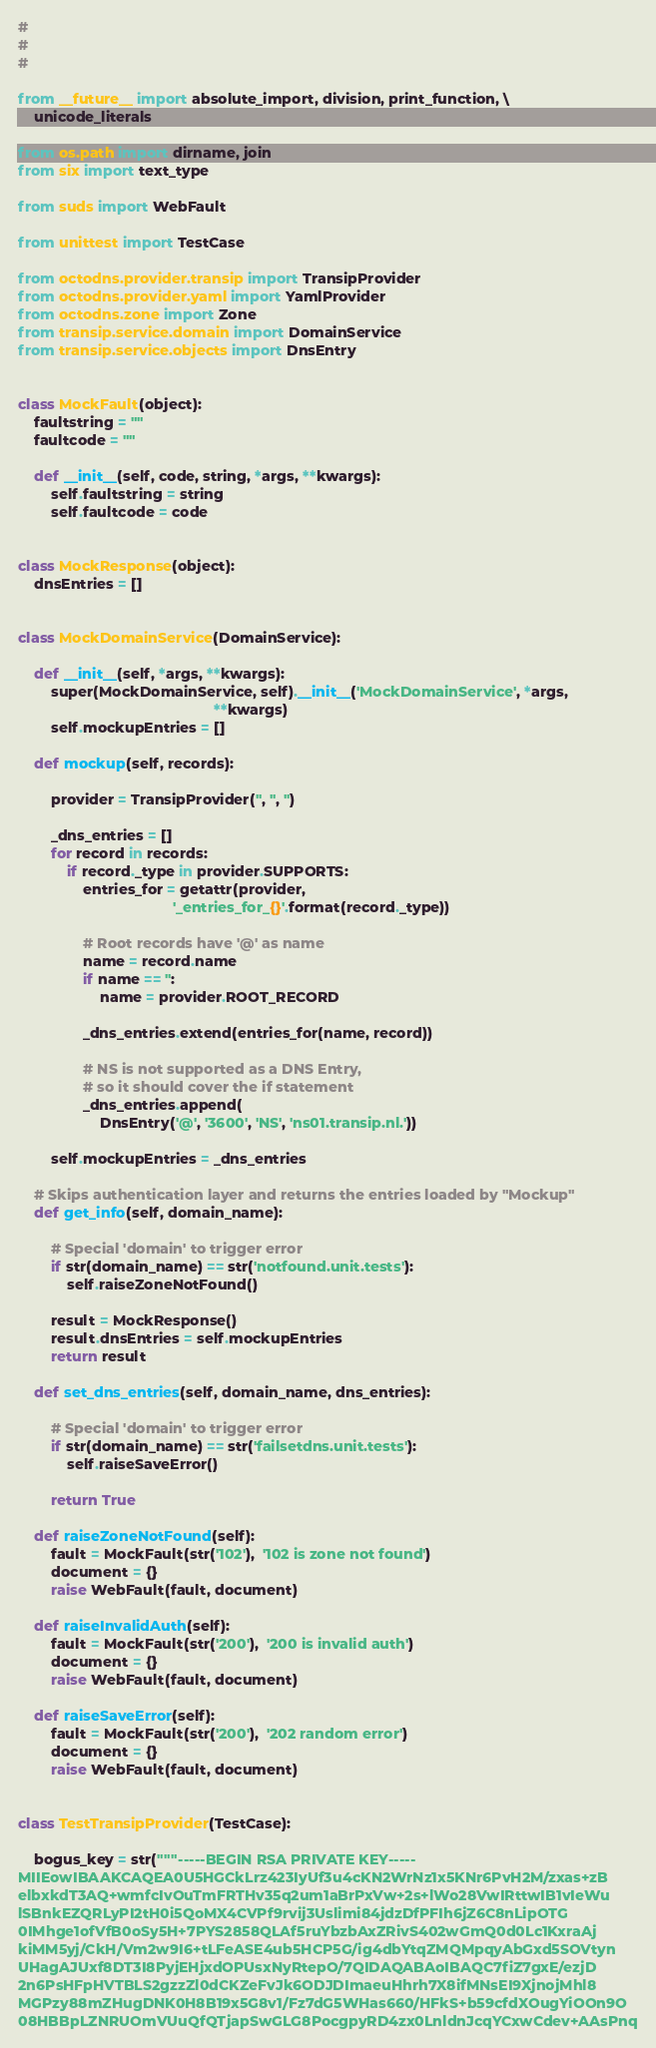Convert code to text. <code><loc_0><loc_0><loc_500><loc_500><_Python_>#
#
#

from __future__ import absolute_import, division, print_function, \
    unicode_literals

from os.path import dirname, join
from six import text_type

from suds import WebFault

from unittest import TestCase

from octodns.provider.transip import TransipProvider
from octodns.provider.yaml import YamlProvider
from octodns.zone import Zone
from transip.service.domain import DomainService
from transip.service.objects import DnsEntry


class MockFault(object):
    faultstring = ""
    faultcode = ""

    def __init__(self, code, string, *args, **kwargs):
        self.faultstring = string
        self.faultcode = code


class MockResponse(object):
    dnsEntries = []


class MockDomainService(DomainService):

    def __init__(self, *args, **kwargs):
        super(MockDomainService, self).__init__('MockDomainService', *args,
                                                **kwargs)
        self.mockupEntries = []

    def mockup(self, records):

        provider = TransipProvider('', '', '')

        _dns_entries = []
        for record in records:
            if record._type in provider.SUPPORTS:
                entries_for = getattr(provider,
                                      '_entries_for_{}'.format(record._type))

                # Root records have '@' as name
                name = record.name
                if name == '':
                    name = provider.ROOT_RECORD

                _dns_entries.extend(entries_for(name, record))

                # NS is not supported as a DNS Entry,
                # so it should cover the if statement
                _dns_entries.append(
                    DnsEntry('@', '3600', 'NS', 'ns01.transip.nl.'))

        self.mockupEntries = _dns_entries

    # Skips authentication layer and returns the entries loaded by "Mockup"
    def get_info(self, domain_name):

        # Special 'domain' to trigger error
        if str(domain_name) == str('notfound.unit.tests'):
            self.raiseZoneNotFound()

        result = MockResponse()
        result.dnsEntries = self.mockupEntries
        return result

    def set_dns_entries(self, domain_name, dns_entries):

        # Special 'domain' to trigger error
        if str(domain_name) == str('failsetdns.unit.tests'):
            self.raiseSaveError()

        return True

    def raiseZoneNotFound(self):
        fault = MockFault(str('102'),  '102 is zone not found')
        document = {}
        raise WebFault(fault, document)

    def raiseInvalidAuth(self):
        fault = MockFault(str('200'),  '200 is invalid auth')
        document = {}
        raise WebFault(fault, document)

    def raiseSaveError(self):
        fault = MockFault(str('200'),  '202 random error')
        document = {}
        raise WebFault(fault, document)


class TestTransipProvider(TestCase):

    bogus_key = str("""-----BEGIN RSA PRIVATE KEY-----
MIIEowIBAAKCAQEA0U5HGCkLrz423IyUf3u4cKN2WrNz1x5KNr6PvH2M/zxas+zB
elbxkdT3AQ+wmfcIvOuTmFRTHv35q2um1aBrPxVw+2s+lWo28VwIRttwIB1vIeWu
lSBnkEZQRLyPI2tH0i5QoMX4CVPf9rvij3Uslimi84jdzDfPFIh6jZ6C8nLipOTG
0IMhge1ofVfB0oSy5H+7PYS2858QLAf5ruYbzbAxZRivS402wGmQ0d0Lc1KxraAj
kiMM5yj/CkH/Vm2w9I6+tLFeASE4ub5HCP5G/ig4dbYtqZMQMpqyAbGxd5SOVtyn
UHagAJUxf8DT3I8PyjEHjxdOPUsxNyRtepO/7QIDAQABAoIBAQC7fiZ7gxE/ezjD
2n6PsHFpHVTBLS2gzzZl0dCKZeFvJk6ODJDImaeuHhrh7X8ifMNsEI9XjnojMhl8
MGPzy88mZHugDNK0H8B19x5G8v1/Fz7dG5WHas660/HFkS+b59cfdXOugYiOOn9O
08HBBpLZNRUOmVUuQfQTjapSwGLG8PocgpyRD4zx0LnldnJcqYCxwCdev+AAsPnq</code> 